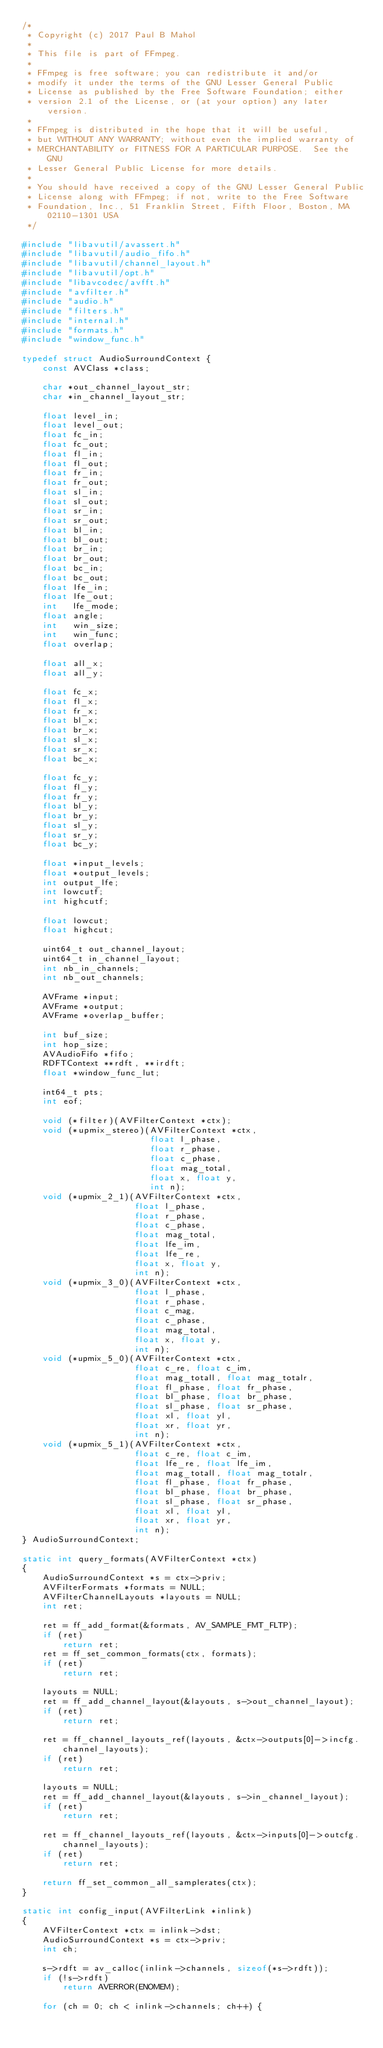Convert code to text. <code><loc_0><loc_0><loc_500><loc_500><_C_>/*
 * Copyright (c) 2017 Paul B Mahol
 *
 * This file is part of FFmpeg.
 *
 * FFmpeg is free software; you can redistribute it and/or
 * modify it under the terms of the GNU Lesser General Public
 * License as published by the Free Software Foundation; either
 * version 2.1 of the License, or (at your option) any later version.
 *
 * FFmpeg is distributed in the hope that it will be useful,
 * but WITHOUT ANY WARRANTY; without even the implied warranty of
 * MERCHANTABILITY or FITNESS FOR A PARTICULAR PURPOSE.  See the GNU
 * Lesser General Public License for more details.
 *
 * You should have received a copy of the GNU Lesser General Public
 * License along with FFmpeg; if not, write to the Free Software
 * Foundation, Inc., 51 Franklin Street, Fifth Floor, Boston, MA 02110-1301 USA
 */

#include "libavutil/avassert.h"
#include "libavutil/audio_fifo.h"
#include "libavutil/channel_layout.h"
#include "libavutil/opt.h"
#include "libavcodec/avfft.h"
#include "avfilter.h"
#include "audio.h"
#include "filters.h"
#include "internal.h"
#include "formats.h"
#include "window_func.h"

typedef struct AudioSurroundContext {
    const AVClass *class;

    char *out_channel_layout_str;
    char *in_channel_layout_str;

    float level_in;
    float level_out;
    float fc_in;
    float fc_out;
    float fl_in;
    float fl_out;
    float fr_in;
    float fr_out;
    float sl_in;
    float sl_out;
    float sr_in;
    float sr_out;
    float bl_in;
    float bl_out;
    float br_in;
    float br_out;
    float bc_in;
    float bc_out;
    float lfe_in;
    float lfe_out;
    int   lfe_mode;
    float angle;
    int   win_size;
    int   win_func;
    float overlap;

    float all_x;
    float all_y;

    float fc_x;
    float fl_x;
    float fr_x;
    float bl_x;
    float br_x;
    float sl_x;
    float sr_x;
    float bc_x;

    float fc_y;
    float fl_y;
    float fr_y;
    float bl_y;
    float br_y;
    float sl_y;
    float sr_y;
    float bc_y;

    float *input_levels;
    float *output_levels;
    int output_lfe;
    int lowcutf;
    int highcutf;

    float lowcut;
    float highcut;

    uint64_t out_channel_layout;
    uint64_t in_channel_layout;
    int nb_in_channels;
    int nb_out_channels;

    AVFrame *input;
    AVFrame *output;
    AVFrame *overlap_buffer;

    int buf_size;
    int hop_size;
    AVAudioFifo *fifo;
    RDFTContext **rdft, **irdft;
    float *window_func_lut;

    int64_t pts;
    int eof;

    void (*filter)(AVFilterContext *ctx);
    void (*upmix_stereo)(AVFilterContext *ctx,
                         float l_phase,
                         float r_phase,
                         float c_phase,
                         float mag_total,
                         float x, float y,
                         int n);
    void (*upmix_2_1)(AVFilterContext *ctx,
                      float l_phase,
                      float r_phase,
                      float c_phase,
                      float mag_total,
                      float lfe_im,
                      float lfe_re,
                      float x, float y,
                      int n);
    void (*upmix_3_0)(AVFilterContext *ctx,
                      float l_phase,
                      float r_phase,
                      float c_mag,
                      float c_phase,
                      float mag_total,
                      float x, float y,
                      int n);
    void (*upmix_5_0)(AVFilterContext *ctx,
                      float c_re, float c_im,
                      float mag_totall, float mag_totalr,
                      float fl_phase, float fr_phase,
                      float bl_phase, float br_phase,
                      float sl_phase, float sr_phase,
                      float xl, float yl,
                      float xr, float yr,
                      int n);
    void (*upmix_5_1)(AVFilterContext *ctx,
                      float c_re, float c_im,
                      float lfe_re, float lfe_im,
                      float mag_totall, float mag_totalr,
                      float fl_phase, float fr_phase,
                      float bl_phase, float br_phase,
                      float sl_phase, float sr_phase,
                      float xl, float yl,
                      float xr, float yr,
                      int n);
} AudioSurroundContext;

static int query_formats(AVFilterContext *ctx)
{
    AudioSurroundContext *s = ctx->priv;
    AVFilterFormats *formats = NULL;
    AVFilterChannelLayouts *layouts = NULL;
    int ret;

    ret = ff_add_format(&formats, AV_SAMPLE_FMT_FLTP);
    if (ret)
        return ret;
    ret = ff_set_common_formats(ctx, formats);
    if (ret)
        return ret;

    layouts = NULL;
    ret = ff_add_channel_layout(&layouts, s->out_channel_layout);
    if (ret)
        return ret;

    ret = ff_channel_layouts_ref(layouts, &ctx->outputs[0]->incfg.channel_layouts);
    if (ret)
        return ret;

    layouts = NULL;
    ret = ff_add_channel_layout(&layouts, s->in_channel_layout);
    if (ret)
        return ret;

    ret = ff_channel_layouts_ref(layouts, &ctx->inputs[0]->outcfg.channel_layouts);
    if (ret)
        return ret;

    return ff_set_common_all_samplerates(ctx);
}

static int config_input(AVFilterLink *inlink)
{
    AVFilterContext *ctx = inlink->dst;
    AudioSurroundContext *s = ctx->priv;
    int ch;

    s->rdft = av_calloc(inlink->channels, sizeof(*s->rdft));
    if (!s->rdft)
        return AVERROR(ENOMEM);

    for (ch = 0; ch < inlink->channels; ch++) {</code> 